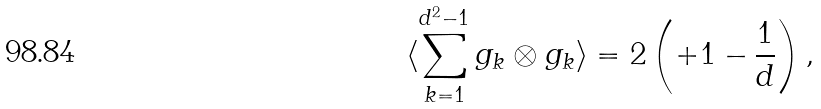<formula> <loc_0><loc_0><loc_500><loc_500>\langle \sum _ { k = 1 } ^ { d ^ { 2 } - 1 } g _ { k } \otimes g _ { k } \rangle = 2 \left ( + 1 - \frac { 1 } { d } \right ) ,</formula> 